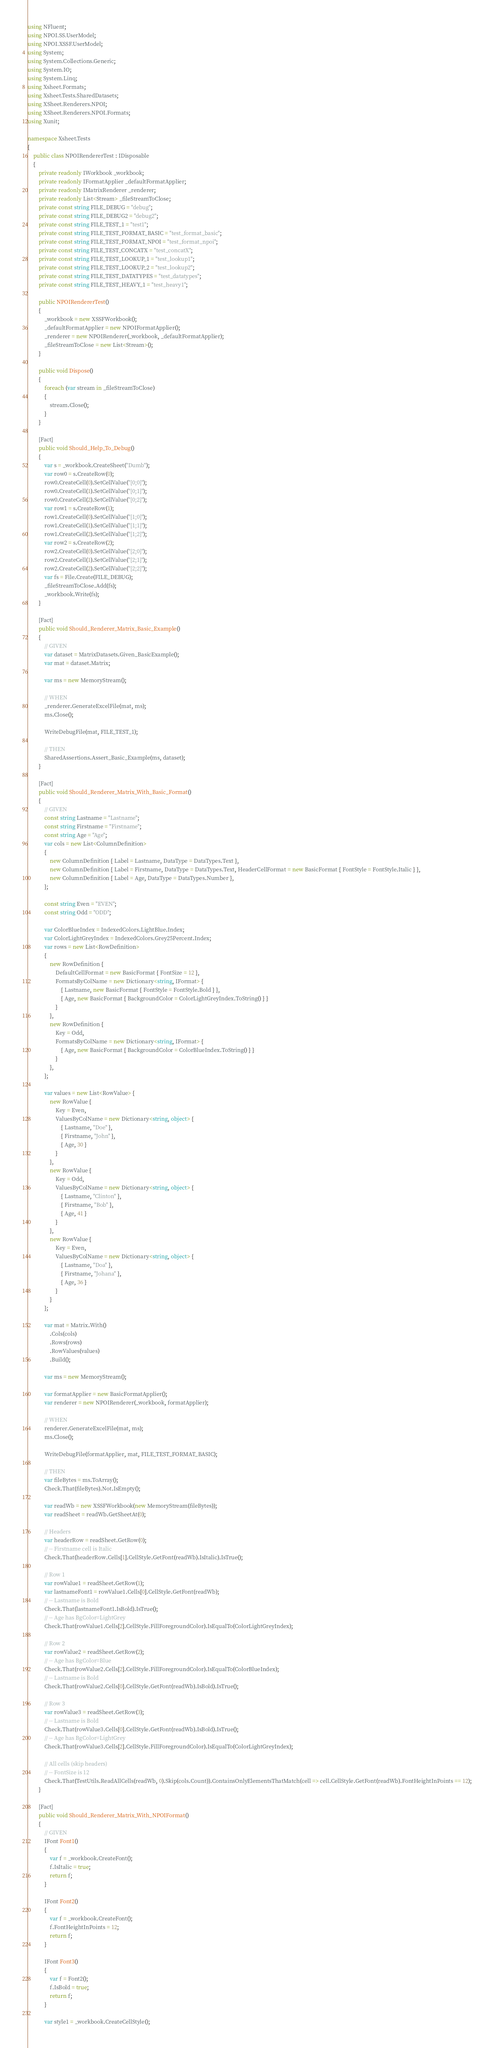<code> <loc_0><loc_0><loc_500><loc_500><_C#_>using NFluent;
using NPOI.SS.UserModel;
using NPOI.XSSF.UserModel;
using System;
using System.Collections.Generic;
using System.IO;
using System.Linq;
using Xsheet.Formats;
using Xsheet.Tests.SharedDatasets;
using XSheet.Renderers.NPOI;
using XSheet.Renderers.NPOI.Formats;
using Xunit;

namespace Xsheet.Tests
{
    public class NPOIRendererTest : IDisposable
    {
        private readonly IWorkbook _workbook;
        private readonly IFormatApplier _defaultFormatApplier;
        private readonly IMatrixRenderer _renderer;
        private readonly List<Stream> _fileStreamToClose;
        private const string FILE_DEBUG = "debug";
        private const string FILE_DEBUG2 = "debug2";
        private const string FILE_TEST_1 = "test1";
        private const string FILE_TEST_FORMAT_BASIC = "test_format_basic";
        private const string FILE_TEST_FORMAT_NPOI = "test_format_npoi";
        private const string FILE_TEST_CONCATX = "test_concatX";
        private const string FILE_TEST_LOOKUP_1 = "test_lookup1";
        private const string FILE_TEST_LOOKUP_2 = "test_lookup2";
        private const string FILE_TEST_DATATYPES = "test_datatypes";
        private const string FILE_TEST_HEAVY_1 = "test_heavy1";

        public NPOIRendererTest()
        {
            _workbook = new XSSFWorkbook();
            _defaultFormatApplier = new NPOIFormatApplier();
            _renderer = new NPOIRenderer(_workbook, _defaultFormatApplier);
            _fileStreamToClose = new List<Stream>();
        }

        public void Dispose()
        {
            foreach (var stream in _fileStreamToClose)
            {
                stream.Close();
            }
        }

        [Fact]
        public void Should_Help_To_Debug()
        {
            var s = _workbook.CreateSheet("Dumb");
            var row0 = s.CreateRow(0);
            row0.CreateCell(0).SetCellValue("[0;0]");
            row0.CreateCell(1).SetCellValue("[0;1]");
            row0.CreateCell(2).SetCellValue("[0;2]");
            var row1 = s.CreateRow(1);
            row1.CreateCell(0).SetCellValue("[1;0]");
            row1.CreateCell(1).SetCellValue("[1;1]");
            row1.CreateCell(2).SetCellValue("[1;2]");
            var row2 = s.CreateRow(2);
            row2.CreateCell(0).SetCellValue("[2;0]");
            row2.CreateCell(1).SetCellValue("[2;1]");
            row2.CreateCell(2).SetCellValue("[2;2]");
            var fs = File.Create(FILE_DEBUG);
            _fileStreamToClose.Add(fs);
            _workbook.Write(fs);
        }

        [Fact]
        public void Should_Renderer_Matrix_Basic_Example()
        {
            // GIVEN
            var dataset = MatrixDatasets.Given_BasicExample();
            var mat = dataset.Matrix;

            var ms = new MemoryStream();

            // WHEN
            _renderer.GenerateExcelFile(mat, ms);
            ms.Close();

            WriteDebugFile(mat, FILE_TEST_1);

            // THEN
            SharedAssertions.Assert_Basic_Example(ms, dataset);
        }

        [Fact]
        public void Should_Renderer_Matrix_With_Basic_Format()
        {
            // GIVEN
            const string Lastname = "Lastname";
            const string Firstname = "Firstname";
            const string Age = "Age";
            var cols = new List<ColumnDefinition>
            {
                new ColumnDefinition { Label = Lastname, DataType = DataTypes.Text },
                new ColumnDefinition { Label = Firstname, DataType = DataTypes.Text, HeaderCellFormat = new BasicFormat { FontStyle = FontStyle.Italic } },
                new ColumnDefinition { Label = Age, DataType = DataTypes.Number },
            };

            const string Even = "EVEN";
            const string Odd = "ODD";

            var ColorBlueIndex = IndexedColors.LightBlue.Index;
            var ColorLightGreyIndex = IndexedColors.Grey25Percent.Index;
            var rows = new List<RowDefinition>
            {
                new RowDefinition {
                    DefaultCellFormat = new BasicFormat { FontSize = 12 },
                    FormatsByColName = new Dictionary<string, IFormat> {
                        { Lastname, new BasicFormat { FontStyle = FontStyle.Bold } },
                        { Age, new BasicFormat { BackgroundColor = ColorLightGreyIndex.ToString() } }
                    }
                },
                new RowDefinition {
                    Key = Odd,
                    FormatsByColName = new Dictionary<string, IFormat> {
                        { Age, new BasicFormat { BackgroundColor = ColorBlueIndex.ToString() } }
                    }
                },
            };

            var values = new List<RowValue> {
                new RowValue {
                    Key = Even,
                    ValuesByColName = new Dictionary<string, object> {
                        { Lastname, "Doe" },
                        { Firstname, "John" },
                        { Age, 30 }
                    }
                },
                new RowValue {
                    Key = Odd,
                    ValuesByColName = new Dictionary<string, object> {
                        { Lastname, "Clinton" },
                        { Firstname, "Bob" },
                        { Age, 41 }
                    }
                },
                new RowValue {
                    Key = Even,
                    ValuesByColName = new Dictionary<string, object> {
                        { Lastname, "Doa" },
                        { Firstname, "Johana" },
                        { Age, 36 }
                    }
                }
            };

            var mat = Matrix.With()
                .Cols(cols)
                .Rows(rows)
                .RowValues(values)
                .Build();

            var ms = new MemoryStream();

            var formatApplier = new BasicFormatApplier();
            var renderer = new NPOIRenderer(_workbook, formatApplier);

            // WHEN
            renderer.GenerateExcelFile(mat, ms);
            ms.Close();

            WriteDebugFile(formatApplier, mat, FILE_TEST_FORMAT_BASIC);

            // THEN
            var fileBytes = ms.ToArray();
            Check.That(fileBytes).Not.IsEmpty();

            var readWb = new XSSFWorkbook(new MemoryStream(fileBytes));
            var readSheet = readWb.GetSheetAt(0);

            // Headers
            var headerRow = readSheet.GetRow(0);
            // -- Firstname cell is Italic
            Check.That(headerRow.Cells[1].CellStyle.GetFont(readWb).IsItalic).IsTrue();

            // Row 1
            var rowValue1 = readSheet.GetRow(1);
            var lastnameFont1 = rowValue1.Cells[0].CellStyle.GetFont(readWb);
            // -- Lastname is Bold
            Check.That(lastnameFont1.IsBold).IsTrue();
            // -- Age has BgColor=LightGrey
            Check.That(rowValue1.Cells[2].CellStyle.FillForegroundColor).IsEqualTo(ColorLightGreyIndex);

            // Row 2
            var rowValue2 = readSheet.GetRow(2);
            // -- Age has BgColor=Blue
            Check.That(rowValue2.Cells[2].CellStyle.FillForegroundColor).IsEqualTo(ColorBlueIndex);
            // -- Lastname is Bold
            Check.That(rowValue2.Cells[0].CellStyle.GetFont(readWb).IsBold).IsTrue();

            // Row 3
            var rowValue3 = readSheet.GetRow(3);
            // -- Lastname is Bold
            Check.That(rowValue3.Cells[0].CellStyle.GetFont(readWb).IsBold).IsTrue();
            // -- Age has BgColor=LightGrey
            Check.That(rowValue3.Cells[2].CellStyle.FillForegroundColor).IsEqualTo(ColorLightGreyIndex);

            // All cells (skip headers)
            // -- FontSize is 12
            Check.That(TestUtils.ReadAllCells(readWb, 0).Skip(cols.Count)).ContainsOnlyElementsThatMatch(cell => cell.CellStyle.GetFont(readWb).FontHeightInPoints == 12);
        }

        [Fact]
        public void Should_Renderer_Matrix_With_NPOIFormat()
        {
            // GIVEN
            IFont Font1()
            {
                var f = _workbook.CreateFont();
                f.IsItalic = true;
                return f;
            }

            IFont Font2()
            {
                var f = _workbook.CreateFont();
                f.FontHeightInPoints = 12;
                return f;
            }

            IFont Font3()
            {
                var f = Font2();
                f.IsBold = true;
                return f;
            }

            var style1 = _workbook.CreateCellStyle();</code> 